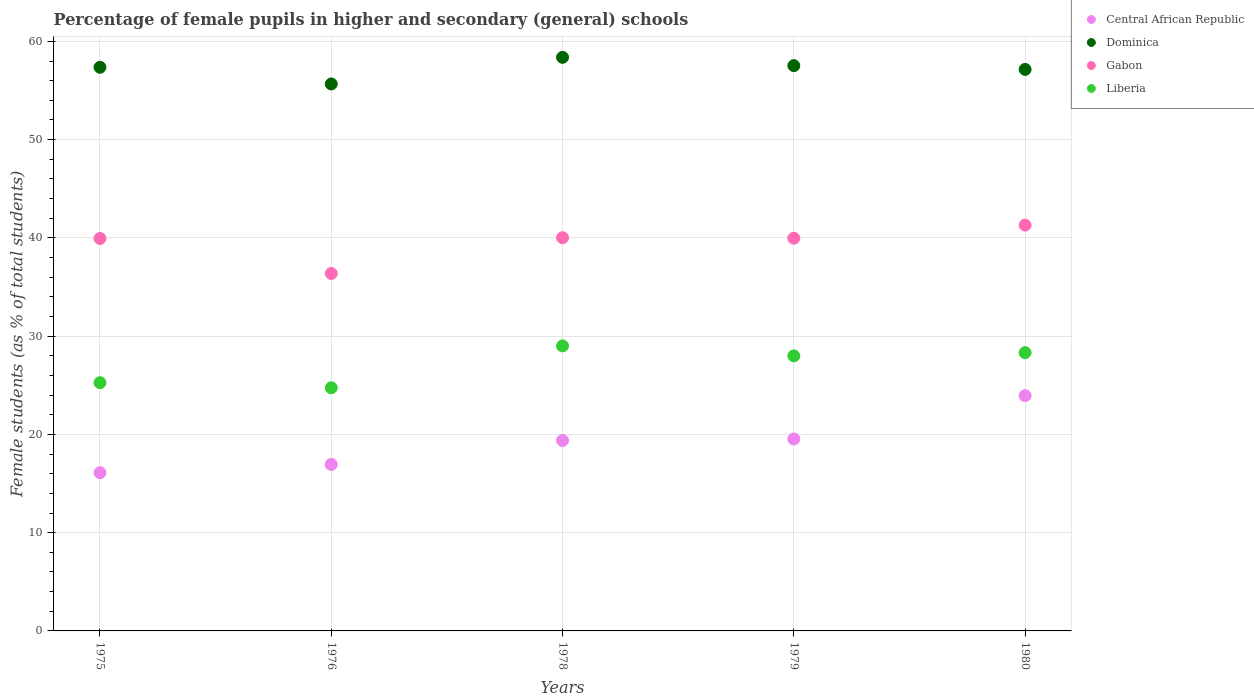How many different coloured dotlines are there?
Your answer should be compact. 4. Is the number of dotlines equal to the number of legend labels?
Ensure brevity in your answer.  Yes. What is the percentage of female pupils in higher and secondary schools in Liberia in 1976?
Keep it short and to the point. 24.74. Across all years, what is the maximum percentage of female pupils in higher and secondary schools in Liberia?
Your answer should be very brief. 29.01. Across all years, what is the minimum percentage of female pupils in higher and secondary schools in Gabon?
Your response must be concise. 36.38. In which year was the percentage of female pupils in higher and secondary schools in Gabon maximum?
Provide a succinct answer. 1980. In which year was the percentage of female pupils in higher and secondary schools in Gabon minimum?
Your answer should be compact. 1976. What is the total percentage of female pupils in higher and secondary schools in Gabon in the graph?
Give a very brief answer. 197.6. What is the difference between the percentage of female pupils in higher and secondary schools in Central African Republic in 1976 and that in 1980?
Your response must be concise. -7.01. What is the difference between the percentage of female pupils in higher and secondary schools in Liberia in 1979 and the percentage of female pupils in higher and secondary schools in Central African Republic in 1975?
Your response must be concise. 11.89. What is the average percentage of female pupils in higher and secondary schools in Central African Republic per year?
Your answer should be very brief. 19.18. In the year 1976, what is the difference between the percentage of female pupils in higher and secondary schools in Dominica and percentage of female pupils in higher and secondary schools in Liberia?
Your response must be concise. 30.92. In how many years, is the percentage of female pupils in higher and secondary schools in Gabon greater than 24 %?
Your answer should be very brief. 5. What is the ratio of the percentage of female pupils in higher and secondary schools in Liberia in 1978 to that in 1980?
Your response must be concise. 1.02. What is the difference between the highest and the second highest percentage of female pupils in higher and secondary schools in Central African Republic?
Your response must be concise. 4.41. What is the difference between the highest and the lowest percentage of female pupils in higher and secondary schools in Central African Republic?
Ensure brevity in your answer.  7.84. In how many years, is the percentage of female pupils in higher and secondary schools in Liberia greater than the average percentage of female pupils in higher and secondary schools in Liberia taken over all years?
Give a very brief answer. 3. Is the sum of the percentage of female pupils in higher and secondary schools in Gabon in 1979 and 1980 greater than the maximum percentage of female pupils in higher and secondary schools in Central African Republic across all years?
Give a very brief answer. Yes. Is it the case that in every year, the sum of the percentage of female pupils in higher and secondary schools in Gabon and percentage of female pupils in higher and secondary schools in Liberia  is greater than the sum of percentage of female pupils in higher and secondary schools in Central African Republic and percentage of female pupils in higher and secondary schools in Dominica?
Provide a short and direct response. Yes. Is the percentage of female pupils in higher and secondary schools in Dominica strictly less than the percentage of female pupils in higher and secondary schools in Liberia over the years?
Your answer should be compact. No. How many dotlines are there?
Provide a succinct answer. 4. Does the graph contain grids?
Keep it short and to the point. Yes. Where does the legend appear in the graph?
Your response must be concise. Top right. How many legend labels are there?
Provide a succinct answer. 4. How are the legend labels stacked?
Ensure brevity in your answer.  Vertical. What is the title of the graph?
Make the answer very short. Percentage of female pupils in higher and secondary (general) schools. What is the label or title of the X-axis?
Your answer should be compact. Years. What is the label or title of the Y-axis?
Your answer should be compact. Female students (as % of total students). What is the Female students (as % of total students) of Central African Republic in 1975?
Give a very brief answer. 16.1. What is the Female students (as % of total students) of Dominica in 1975?
Your answer should be very brief. 57.36. What is the Female students (as % of total students) in Gabon in 1975?
Your answer should be very brief. 39.94. What is the Female students (as % of total students) of Liberia in 1975?
Keep it short and to the point. 25.26. What is the Female students (as % of total students) of Central African Republic in 1976?
Provide a short and direct response. 16.94. What is the Female students (as % of total students) of Dominica in 1976?
Offer a very short reply. 55.66. What is the Female students (as % of total students) in Gabon in 1976?
Provide a short and direct response. 36.38. What is the Female students (as % of total students) in Liberia in 1976?
Give a very brief answer. 24.74. What is the Female students (as % of total students) in Central African Republic in 1978?
Your answer should be very brief. 19.38. What is the Female students (as % of total students) in Dominica in 1978?
Offer a terse response. 58.37. What is the Female students (as % of total students) of Gabon in 1978?
Ensure brevity in your answer.  40.02. What is the Female students (as % of total students) in Liberia in 1978?
Your answer should be compact. 29.01. What is the Female students (as % of total students) in Central African Republic in 1979?
Provide a succinct answer. 19.54. What is the Female students (as % of total students) in Dominica in 1979?
Ensure brevity in your answer.  57.53. What is the Female students (as % of total students) of Gabon in 1979?
Your response must be concise. 39.97. What is the Female students (as % of total students) of Liberia in 1979?
Ensure brevity in your answer.  27.99. What is the Female students (as % of total students) of Central African Republic in 1980?
Your answer should be compact. 23.94. What is the Female students (as % of total students) of Dominica in 1980?
Offer a very short reply. 57.14. What is the Female students (as % of total students) of Gabon in 1980?
Make the answer very short. 41.3. What is the Female students (as % of total students) in Liberia in 1980?
Ensure brevity in your answer.  28.32. Across all years, what is the maximum Female students (as % of total students) in Central African Republic?
Provide a succinct answer. 23.94. Across all years, what is the maximum Female students (as % of total students) in Dominica?
Offer a terse response. 58.37. Across all years, what is the maximum Female students (as % of total students) in Gabon?
Your response must be concise. 41.3. Across all years, what is the maximum Female students (as % of total students) in Liberia?
Keep it short and to the point. 29.01. Across all years, what is the minimum Female students (as % of total students) of Central African Republic?
Keep it short and to the point. 16.1. Across all years, what is the minimum Female students (as % of total students) of Dominica?
Ensure brevity in your answer.  55.66. Across all years, what is the minimum Female students (as % of total students) of Gabon?
Your response must be concise. 36.38. Across all years, what is the minimum Female students (as % of total students) of Liberia?
Provide a succinct answer. 24.74. What is the total Female students (as % of total students) in Central African Republic in the graph?
Make the answer very short. 95.89. What is the total Female students (as % of total students) in Dominica in the graph?
Keep it short and to the point. 286.07. What is the total Female students (as % of total students) in Gabon in the graph?
Your response must be concise. 197.6. What is the total Female students (as % of total students) of Liberia in the graph?
Give a very brief answer. 135.33. What is the difference between the Female students (as % of total students) of Central African Republic in 1975 and that in 1976?
Keep it short and to the point. -0.84. What is the difference between the Female students (as % of total students) of Dominica in 1975 and that in 1976?
Keep it short and to the point. 1.7. What is the difference between the Female students (as % of total students) in Gabon in 1975 and that in 1976?
Keep it short and to the point. 3.56. What is the difference between the Female students (as % of total students) in Liberia in 1975 and that in 1976?
Your answer should be very brief. 0.52. What is the difference between the Female students (as % of total students) in Central African Republic in 1975 and that in 1978?
Ensure brevity in your answer.  -3.28. What is the difference between the Female students (as % of total students) in Dominica in 1975 and that in 1978?
Make the answer very short. -1.01. What is the difference between the Female students (as % of total students) in Gabon in 1975 and that in 1978?
Keep it short and to the point. -0.08. What is the difference between the Female students (as % of total students) in Liberia in 1975 and that in 1978?
Ensure brevity in your answer.  -3.74. What is the difference between the Female students (as % of total students) in Central African Republic in 1975 and that in 1979?
Your response must be concise. -3.44. What is the difference between the Female students (as % of total students) of Dominica in 1975 and that in 1979?
Provide a succinct answer. -0.17. What is the difference between the Female students (as % of total students) in Gabon in 1975 and that in 1979?
Provide a succinct answer. -0.03. What is the difference between the Female students (as % of total students) in Liberia in 1975 and that in 1979?
Your answer should be compact. -2.73. What is the difference between the Female students (as % of total students) in Central African Republic in 1975 and that in 1980?
Provide a succinct answer. -7.84. What is the difference between the Female students (as % of total students) of Dominica in 1975 and that in 1980?
Provide a succinct answer. 0.22. What is the difference between the Female students (as % of total students) of Gabon in 1975 and that in 1980?
Ensure brevity in your answer.  -1.36. What is the difference between the Female students (as % of total students) of Liberia in 1975 and that in 1980?
Your answer should be compact. -3.06. What is the difference between the Female students (as % of total students) of Central African Republic in 1976 and that in 1978?
Your answer should be compact. -2.44. What is the difference between the Female students (as % of total students) of Dominica in 1976 and that in 1978?
Offer a very short reply. -2.71. What is the difference between the Female students (as % of total students) of Gabon in 1976 and that in 1978?
Keep it short and to the point. -3.64. What is the difference between the Female students (as % of total students) of Liberia in 1976 and that in 1978?
Offer a very short reply. -4.26. What is the difference between the Female students (as % of total students) of Central African Republic in 1976 and that in 1979?
Make the answer very short. -2.6. What is the difference between the Female students (as % of total students) of Dominica in 1976 and that in 1979?
Offer a very short reply. -1.86. What is the difference between the Female students (as % of total students) of Gabon in 1976 and that in 1979?
Your response must be concise. -3.59. What is the difference between the Female students (as % of total students) in Liberia in 1976 and that in 1979?
Your answer should be compact. -3.25. What is the difference between the Female students (as % of total students) in Central African Republic in 1976 and that in 1980?
Your answer should be very brief. -7.01. What is the difference between the Female students (as % of total students) of Dominica in 1976 and that in 1980?
Offer a terse response. -1.48. What is the difference between the Female students (as % of total students) in Gabon in 1976 and that in 1980?
Your answer should be compact. -4.92. What is the difference between the Female students (as % of total students) of Liberia in 1976 and that in 1980?
Offer a terse response. -3.58. What is the difference between the Female students (as % of total students) of Central African Republic in 1978 and that in 1979?
Provide a short and direct response. -0.16. What is the difference between the Female students (as % of total students) in Dominica in 1978 and that in 1979?
Offer a terse response. 0.84. What is the difference between the Female students (as % of total students) of Gabon in 1978 and that in 1979?
Make the answer very short. 0.05. What is the difference between the Female students (as % of total students) in Liberia in 1978 and that in 1979?
Your response must be concise. 1.01. What is the difference between the Female students (as % of total students) of Central African Republic in 1978 and that in 1980?
Provide a short and direct response. -4.56. What is the difference between the Female students (as % of total students) of Dominica in 1978 and that in 1980?
Keep it short and to the point. 1.23. What is the difference between the Female students (as % of total students) in Gabon in 1978 and that in 1980?
Give a very brief answer. -1.28. What is the difference between the Female students (as % of total students) of Liberia in 1978 and that in 1980?
Ensure brevity in your answer.  0.69. What is the difference between the Female students (as % of total students) in Central African Republic in 1979 and that in 1980?
Provide a succinct answer. -4.41. What is the difference between the Female students (as % of total students) in Dominica in 1979 and that in 1980?
Offer a terse response. 0.39. What is the difference between the Female students (as % of total students) of Gabon in 1979 and that in 1980?
Offer a terse response. -1.33. What is the difference between the Female students (as % of total students) in Liberia in 1979 and that in 1980?
Offer a terse response. -0.33. What is the difference between the Female students (as % of total students) in Central African Republic in 1975 and the Female students (as % of total students) in Dominica in 1976?
Your response must be concise. -39.56. What is the difference between the Female students (as % of total students) of Central African Republic in 1975 and the Female students (as % of total students) of Gabon in 1976?
Your answer should be compact. -20.28. What is the difference between the Female students (as % of total students) in Central African Republic in 1975 and the Female students (as % of total students) in Liberia in 1976?
Keep it short and to the point. -8.64. What is the difference between the Female students (as % of total students) in Dominica in 1975 and the Female students (as % of total students) in Gabon in 1976?
Offer a terse response. 20.98. What is the difference between the Female students (as % of total students) of Dominica in 1975 and the Female students (as % of total students) of Liberia in 1976?
Your answer should be very brief. 32.62. What is the difference between the Female students (as % of total students) in Gabon in 1975 and the Female students (as % of total students) in Liberia in 1976?
Your answer should be very brief. 15.19. What is the difference between the Female students (as % of total students) of Central African Republic in 1975 and the Female students (as % of total students) of Dominica in 1978?
Provide a short and direct response. -42.27. What is the difference between the Female students (as % of total students) of Central African Republic in 1975 and the Female students (as % of total students) of Gabon in 1978?
Ensure brevity in your answer.  -23.92. What is the difference between the Female students (as % of total students) of Central African Republic in 1975 and the Female students (as % of total students) of Liberia in 1978?
Your answer should be very brief. -12.91. What is the difference between the Female students (as % of total students) of Dominica in 1975 and the Female students (as % of total students) of Gabon in 1978?
Keep it short and to the point. 17.35. What is the difference between the Female students (as % of total students) in Dominica in 1975 and the Female students (as % of total students) in Liberia in 1978?
Your answer should be compact. 28.35. What is the difference between the Female students (as % of total students) of Gabon in 1975 and the Female students (as % of total students) of Liberia in 1978?
Ensure brevity in your answer.  10.93. What is the difference between the Female students (as % of total students) in Central African Republic in 1975 and the Female students (as % of total students) in Dominica in 1979?
Provide a short and direct response. -41.43. What is the difference between the Female students (as % of total students) in Central African Republic in 1975 and the Female students (as % of total students) in Gabon in 1979?
Give a very brief answer. -23.87. What is the difference between the Female students (as % of total students) of Central African Republic in 1975 and the Female students (as % of total students) of Liberia in 1979?
Make the answer very short. -11.89. What is the difference between the Female students (as % of total students) in Dominica in 1975 and the Female students (as % of total students) in Gabon in 1979?
Give a very brief answer. 17.39. What is the difference between the Female students (as % of total students) in Dominica in 1975 and the Female students (as % of total students) in Liberia in 1979?
Make the answer very short. 29.37. What is the difference between the Female students (as % of total students) in Gabon in 1975 and the Female students (as % of total students) in Liberia in 1979?
Make the answer very short. 11.94. What is the difference between the Female students (as % of total students) of Central African Republic in 1975 and the Female students (as % of total students) of Dominica in 1980?
Offer a very short reply. -41.04. What is the difference between the Female students (as % of total students) of Central African Republic in 1975 and the Female students (as % of total students) of Gabon in 1980?
Ensure brevity in your answer.  -25.2. What is the difference between the Female students (as % of total students) in Central African Republic in 1975 and the Female students (as % of total students) in Liberia in 1980?
Provide a succinct answer. -12.22. What is the difference between the Female students (as % of total students) of Dominica in 1975 and the Female students (as % of total students) of Gabon in 1980?
Keep it short and to the point. 16.06. What is the difference between the Female students (as % of total students) of Dominica in 1975 and the Female students (as % of total students) of Liberia in 1980?
Your response must be concise. 29.04. What is the difference between the Female students (as % of total students) of Gabon in 1975 and the Female students (as % of total students) of Liberia in 1980?
Give a very brief answer. 11.62. What is the difference between the Female students (as % of total students) of Central African Republic in 1976 and the Female students (as % of total students) of Dominica in 1978?
Ensure brevity in your answer.  -41.44. What is the difference between the Female students (as % of total students) of Central African Republic in 1976 and the Female students (as % of total students) of Gabon in 1978?
Provide a succinct answer. -23.08. What is the difference between the Female students (as % of total students) of Central African Republic in 1976 and the Female students (as % of total students) of Liberia in 1978?
Keep it short and to the point. -12.07. What is the difference between the Female students (as % of total students) in Dominica in 1976 and the Female students (as % of total students) in Gabon in 1978?
Your answer should be compact. 15.65. What is the difference between the Female students (as % of total students) in Dominica in 1976 and the Female students (as % of total students) in Liberia in 1978?
Your answer should be compact. 26.66. What is the difference between the Female students (as % of total students) of Gabon in 1976 and the Female students (as % of total students) of Liberia in 1978?
Offer a terse response. 7.37. What is the difference between the Female students (as % of total students) in Central African Republic in 1976 and the Female students (as % of total students) in Dominica in 1979?
Give a very brief answer. -40.59. What is the difference between the Female students (as % of total students) of Central African Republic in 1976 and the Female students (as % of total students) of Gabon in 1979?
Ensure brevity in your answer.  -23.03. What is the difference between the Female students (as % of total students) in Central African Republic in 1976 and the Female students (as % of total students) in Liberia in 1979?
Provide a succinct answer. -11.06. What is the difference between the Female students (as % of total students) of Dominica in 1976 and the Female students (as % of total students) of Gabon in 1979?
Offer a very short reply. 15.7. What is the difference between the Female students (as % of total students) of Dominica in 1976 and the Female students (as % of total students) of Liberia in 1979?
Provide a short and direct response. 27.67. What is the difference between the Female students (as % of total students) in Gabon in 1976 and the Female students (as % of total students) in Liberia in 1979?
Your response must be concise. 8.38. What is the difference between the Female students (as % of total students) in Central African Republic in 1976 and the Female students (as % of total students) in Dominica in 1980?
Provide a short and direct response. -40.21. What is the difference between the Female students (as % of total students) of Central African Republic in 1976 and the Female students (as % of total students) of Gabon in 1980?
Your answer should be compact. -24.36. What is the difference between the Female students (as % of total students) in Central African Republic in 1976 and the Female students (as % of total students) in Liberia in 1980?
Provide a short and direct response. -11.38. What is the difference between the Female students (as % of total students) in Dominica in 1976 and the Female students (as % of total students) in Gabon in 1980?
Make the answer very short. 14.37. What is the difference between the Female students (as % of total students) in Dominica in 1976 and the Female students (as % of total students) in Liberia in 1980?
Ensure brevity in your answer.  27.34. What is the difference between the Female students (as % of total students) in Gabon in 1976 and the Female students (as % of total students) in Liberia in 1980?
Your answer should be very brief. 8.06. What is the difference between the Female students (as % of total students) of Central African Republic in 1978 and the Female students (as % of total students) of Dominica in 1979?
Offer a very short reply. -38.15. What is the difference between the Female students (as % of total students) of Central African Republic in 1978 and the Female students (as % of total students) of Gabon in 1979?
Keep it short and to the point. -20.59. What is the difference between the Female students (as % of total students) in Central African Republic in 1978 and the Female students (as % of total students) in Liberia in 1979?
Make the answer very short. -8.61. What is the difference between the Female students (as % of total students) of Dominica in 1978 and the Female students (as % of total students) of Gabon in 1979?
Provide a short and direct response. 18.4. What is the difference between the Female students (as % of total students) in Dominica in 1978 and the Female students (as % of total students) in Liberia in 1979?
Offer a very short reply. 30.38. What is the difference between the Female students (as % of total students) in Gabon in 1978 and the Female students (as % of total students) in Liberia in 1979?
Keep it short and to the point. 12.02. What is the difference between the Female students (as % of total students) in Central African Republic in 1978 and the Female students (as % of total students) in Dominica in 1980?
Your answer should be very brief. -37.76. What is the difference between the Female students (as % of total students) in Central African Republic in 1978 and the Female students (as % of total students) in Gabon in 1980?
Give a very brief answer. -21.92. What is the difference between the Female students (as % of total students) of Central African Republic in 1978 and the Female students (as % of total students) of Liberia in 1980?
Offer a terse response. -8.94. What is the difference between the Female students (as % of total students) of Dominica in 1978 and the Female students (as % of total students) of Gabon in 1980?
Your answer should be very brief. 17.07. What is the difference between the Female students (as % of total students) of Dominica in 1978 and the Female students (as % of total students) of Liberia in 1980?
Provide a succinct answer. 30.05. What is the difference between the Female students (as % of total students) of Gabon in 1978 and the Female students (as % of total students) of Liberia in 1980?
Offer a terse response. 11.7. What is the difference between the Female students (as % of total students) in Central African Republic in 1979 and the Female students (as % of total students) in Dominica in 1980?
Give a very brief answer. -37.61. What is the difference between the Female students (as % of total students) of Central African Republic in 1979 and the Female students (as % of total students) of Gabon in 1980?
Offer a terse response. -21.76. What is the difference between the Female students (as % of total students) of Central African Republic in 1979 and the Female students (as % of total students) of Liberia in 1980?
Give a very brief answer. -8.79. What is the difference between the Female students (as % of total students) of Dominica in 1979 and the Female students (as % of total students) of Gabon in 1980?
Offer a terse response. 16.23. What is the difference between the Female students (as % of total students) in Dominica in 1979 and the Female students (as % of total students) in Liberia in 1980?
Provide a succinct answer. 29.21. What is the difference between the Female students (as % of total students) in Gabon in 1979 and the Female students (as % of total students) in Liberia in 1980?
Offer a very short reply. 11.65. What is the average Female students (as % of total students) in Central African Republic per year?
Provide a succinct answer. 19.18. What is the average Female students (as % of total students) of Dominica per year?
Provide a short and direct response. 57.21. What is the average Female students (as % of total students) in Gabon per year?
Offer a terse response. 39.52. What is the average Female students (as % of total students) of Liberia per year?
Make the answer very short. 27.07. In the year 1975, what is the difference between the Female students (as % of total students) of Central African Republic and Female students (as % of total students) of Dominica?
Provide a short and direct response. -41.26. In the year 1975, what is the difference between the Female students (as % of total students) of Central African Republic and Female students (as % of total students) of Gabon?
Give a very brief answer. -23.84. In the year 1975, what is the difference between the Female students (as % of total students) of Central African Republic and Female students (as % of total students) of Liberia?
Offer a terse response. -9.16. In the year 1975, what is the difference between the Female students (as % of total students) of Dominica and Female students (as % of total students) of Gabon?
Offer a terse response. 17.42. In the year 1975, what is the difference between the Female students (as % of total students) in Dominica and Female students (as % of total students) in Liberia?
Your answer should be compact. 32.1. In the year 1975, what is the difference between the Female students (as % of total students) of Gabon and Female students (as % of total students) of Liberia?
Keep it short and to the point. 14.68. In the year 1976, what is the difference between the Female students (as % of total students) in Central African Republic and Female students (as % of total students) in Dominica?
Make the answer very short. -38.73. In the year 1976, what is the difference between the Female students (as % of total students) of Central African Republic and Female students (as % of total students) of Gabon?
Provide a succinct answer. -19.44. In the year 1976, what is the difference between the Female students (as % of total students) of Central African Republic and Female students (as % of total students) of Liberia?
Give a very brief answer. -7.81. In the year 1976, what is the difference between the Female students (as % of total students) in Dominica and Female students (as % of total students) in Gabon?
Your response must be concise. 19.29. In the year 1976, what is the difference between the Female students (as % of total students) of Dominica and Female students (as % of total students) of Liberia?
Keep it short and to the point. 30.92. In the year 1976, what is the difference between the Female students (as % of total students) in Gabon and Female students (as % of total students) in Liberia?
Your response must be concise. 11.63. In the year 1978, what is the difference between the Female students (as % of total students) in Central African Republic and Female students (as % of total students) in Dominica?
Give a very brief answer. -38.99. In the year 1978, what is the difference between the Female students (as % of total students) of Central African Republic and Female students (as % of total students) of Gabon?
Your answer should be very brief. -20.64. In the year 1978, what is the difference between the Female students (as % of total students) in Central African Republic and Female students (as % of total students) in Liberia?
Give a very brief answer. -9.63. In the year 1978, what is the difference between the Female students (as % of total students) in Dominica and Female students (as % of total students) in Gabon?
Ensure brevity in your answer.  18.36. In the year 1978, what is the difference between the Female students (as % of total students) in Dominica and Female students (as % of total students) in Liberia?
Give a very brief answer. 29.37. In the year 1978, what is the difference between the Female students (as % of total students) in Gabon and Female students (as % of total students) in Liberia?
Provide a succinct answer. 11.01. In the year 1979, what is the difference between the Female students (as % of total students) in Central African Republic and Female students (as % of total students) in Dominica?
Ensure brevity in your answer.  -37.99. In the year 1979, what is the difference between the Female students (as % of total students) in Central African Republic and Female students (as % of total students) in Gabon?
Your answer should be very brief. -20.43. In the year 1979, what is the difference between the Female students (as % of total students) in Central African Republic and Female students (as % of total students) in Liberia?
Offer a very short reply. -8.46. In the year 1979, what is the difference between the Female students (as % of total students) of Dominica and Female students (as % of total students) of Gabon?
Your answer should be compact. 17.56. In the year 1979, what is the difference between the Female students (as % of total students) in Dominica and Female students (as % of total students) in Liberia?
Keep it short and to the point. 29.54. In the year 1979, what is the difference between the Female students (as % of total students) in Gabon and Female students (as % of total students) in Liberia?
Make the answer very short. 11.97. In the year 1980, what is the difference between the Female students (as % of total students) of Central African Republic and Female students (as % of total students) of Dominica?
Give a very brief answer. -33.2. In the year 1980, what is the difference between the Female students (as % of total students) in Central African Republic and Female students (as % of total students) in Gabon?
Provide a succinct answer. -17.35. In the year 1980, what is the difference between the Female students (as % of total students) in Central African Republic and Female students (as % of total students) in Liberia?
Offer a terse response. -4.38. In the year 1980, what is the difference between the Female students (as % of total students) in Dominica and Female students (as % of total students) in Gabon?
Provide a short and direct response. 15.85. In the year 1980, what is the difference between the Female students (as % of total students) of Dominica and Female students (as % of total students) of Liberia?
Your response must be concise. 28.82. In the year 1980, what is the difference between the Female students (as % of total students) in Gabon and Female students (as % of total students) in Liberia?
Make the answer very short. 12.98. What is the ratio of the Female students (as % of total students) in Central African Republic in 1975 to that in 1976?
Keep it short and to the point. 0.95. What is the ratio of the Female students (as % of total students) of Dominica in 1975 to that in 1976?
Ensure brevity in your answer.  1.03. What is the ratio of the Female students (as % of total students) in Gabon in 1975 to that in 1976?
Provide a short and direct response. 1.1. What is the ratio of the Female students (as % of total students) of Liberia in 1975 to that in 1976?
Your response must be concise. 1.02. What is the ratio of the Female students (as % of total students) of Central African Republic in 1975 to that in 1978?
Provide a succinct answer. 0.83. What is the ratio of the Female students (as % of total students) in Dominica in 1975 to that in 1978?
Provide a succinct answer. 0.98. What is the ratio of the Female students (as % of total students) of Gabon in 1975 to that in 1978?
Provide a succinct answer. 1. What is the ratio of the Female students (as % of total students) of Liberia in 1975 to that in 1978?
Provide a short and direct response. 0.87. What is the ratio of the Female students (as % of total students) of Central African Republic in 1975 to that in 1979?
Keep it short and to the point. 0.82. What is the ratio of the Female students (as % of total students) of Dominica in 1975 to that in 1979?
Provide a short and direct response. 1. What is the ratio of the Female students (as % of total students) of Gabon in 1975 to that in 1979?
Offer a very short reply. 1. What is the ratio of the Female students (as % of total students) of Liberia in 1975 to that in 1979?
Your answer should be compact. 0.9. What is the ratio of the Female students (as % of total students) in Central African Republic in 1975 to that in 1980?
Make the answer very short. 0.67. What is the ratio of the Female students (as % of total students) in Gabon in 1975 to that in 1980?
Provide a succinct answer. 0.97. What is the ratio of the Female students (as % of total students) of Liberia in 1975 to that in 1980?
Offer a very short reply. 0.89. What is the ratio of the Female students (as % of total students) of Central African Republic in 1976 to that in 1978?
Provide a short and direct response. 0.87. What is the ratio of the Female students (as % of total students) in Dominica in 1976 to that in 1978?
Your answer should be compact. 0.95. What is the ratio of the Female students (as % of total students) of Gabon in 1976 to that in 1978?
Keep it short and to the point. 0.91. What is the ratio of the Female students (as % of total students) of Liberia in 1976 to that in 1978?
Give a very brief answer. 0.85. What is the ratio of the Female students (as % of total students) of Central African Republic in 1976 to that in 1979?
Your response must be concise. 0.87. What is the ratio of the Female students (as % of total students) of Dominica in 1976 to that in 1979?
Ensure brevity in your answer.  0.97. What is the ratio of the Female students (as % of total students) in Gabon in 1976 to that in 1979?
Offer a terse response. 0.91. What is the ratio of the Female students (as % of total students) in Liberia in 1976 to that in 1979?
Your response must be concise. 0.88. What is the ratio of the Female students (as % of total students) of Central African Republic in 1976 to that in 1980?
Your answer should be compact. 0.71. What is the ratio of the Female students (as % of total students) of Dominica in 1976 to that in 1980?
Give a very brief answer. 0.97. What is the ratio of the Female students (as % of total students) in Gabon in 1976 to that in 1980?
Provide a succinct answer. 0.88. What is the ratio of the Female students (as % of total students) of Liberia in 1976 to that in 1980?
Keep it short and to the point. 0.87. What is the ratio of the Female students (as % of total students) of Dominica in 1978 to that in 1979?
Provide a short and direct response. 1.01. What is the ratio of the Female students (as % of total students) of Gabon in 1978 to that in 1979?
Ensure brevity in your answer.  1. What is the ratio of the Female students (as % of total students) of Liberia in 1978 to that in 1979?
Keep it short and to the point. 1.04. What is the ratio of the Female students (as % of total students) in Central African Republic in 1978 to that in 1980?
Give a very brief answer. 0.81. What is the ratio of the Female students (as % of total students) of Dominica in 1978 to that in 1980?
Your answer should be very brief. 1.02. What is the ratio of the Female students (as % of total students) in Liberia in 1978 to that in 1980?
Your response must be concise. 1.02. What is the ratio of the Female students (as % of total students) in Central African Republic in 1979 to that in 1980?
Your answer should be very brief. 0.82. What is the ratio of the Female students (as % of total students) of Gabon in 1979 to that in 1980?
Provide a short and direct response. 0.97. What is the ratio of the Female students (as % of total students) in Liberia in 1979 to that in 1980?
Provide a short and direct response. 0.99. What is the difference between the highest and the second highest Female students (as % of total students) of Central African Republic?
Your answer should be compact. 4.41. What is the difference between the highest and the second highest Female students (as % of total students) in Dominica?
Ensure brevity in your answer.  0.84. What is the difference between the highest and the second highest Female students (as % of total students) in Gabon?
Your answer should be compact. 1.28. What is the difference between the highest and the second highest Female students (as % of total students) in Liberia?
Provide a short and direct response. 0.69. What is the difference between the highest and the lowest Female students (as % of total students) of Central African Republic?
Your response must be concise. 7.84. What is the difference between the highest and the lowest Female students (as % of total students) of Dominica?
Offer a very short reply. 2.71. What is the difference between the highest and the lowest Female students (as % of total students) of Gabon?
Your response must be concise. 4.92. What is the difference between the highest and the lowest Female students (as % of total students) in Liberia?
Ensure brevity in your answer.  4.26. 